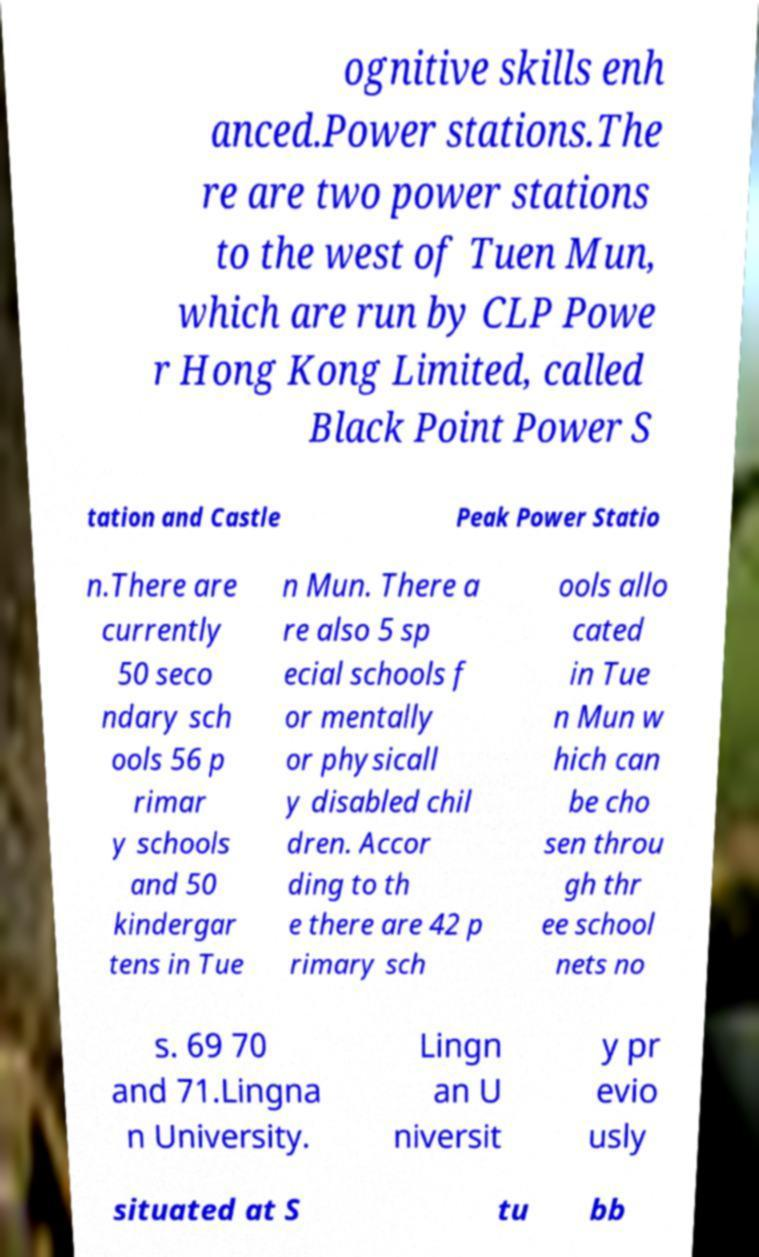Could you assist in decoding the text presented in this image and type it out clearly? ognitive skills enh anced.Power stations.The re are two power stations to the west of Tuen Mun, which are run by CLP Powe r Hong Kong Limited, called Black Point Power S tation and Castle Peak Power Statio n.There are currently 50 seco ndary sch ools 56 p rimar y schools and 50 kindergar tens in Tue n Mun. There a re also 5 sp ecial schools f or mentally or physicall y disabled chil dren. Accor ding to th e there are 42 p rimary sch ools allo cated in Tue n Mun w hich can be cho sen throu gh thr ee school nets no s. 69 70 and 71.Lingna n University. Lingn an U niversit y pr evio usly situated at S tu bb 